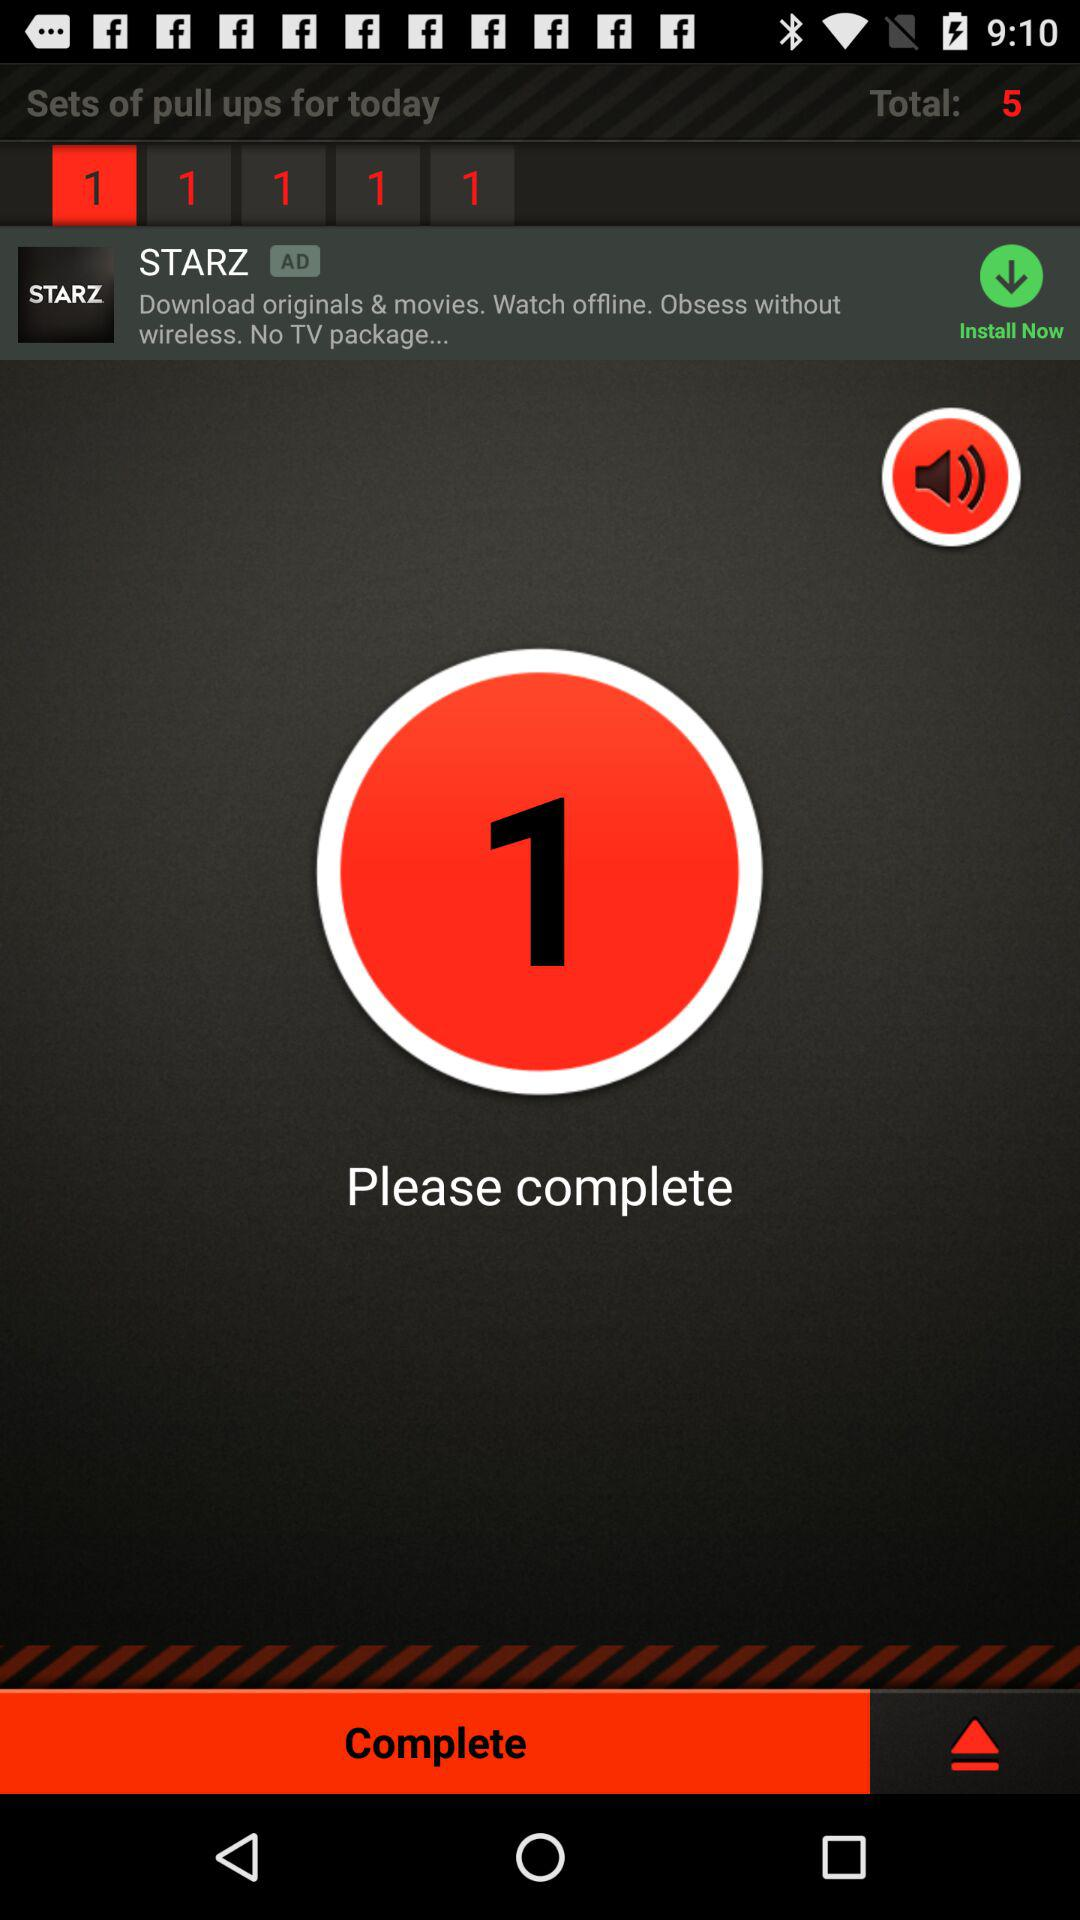How many pull ups were completed yesterday?
When the provided information is insufficient, respond with <no answer>. <no answer> 